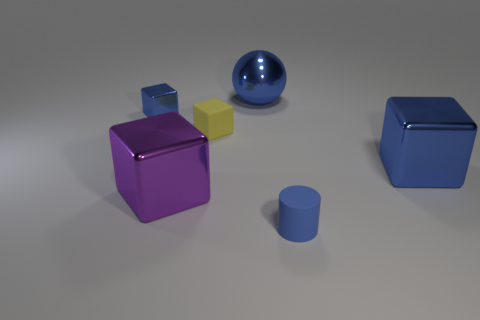Add 1 gray metallic cubes. How many objects exist? 7 Subtract all cylinders. How many objects are left? 5 Add 6 blue cylinders. How many blue cylinders exist? 7 Subtract 1 blue balls. How many objects are left? 5 Subtract all cylinders. Subtract all small blue shiny objects. How many objects are left? 4 Add 4 small matte blocks. How many small matte blocks are left? 5 